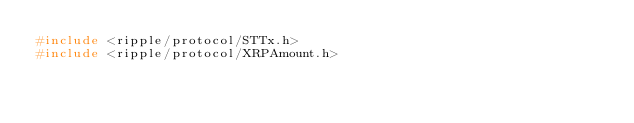<code> <loc_0><loc_0><loc_500><loc_500><_C_>#include <ripple/protocol/STTx.h>
#include <ripple/protocol/XRPAmount.h></code> 